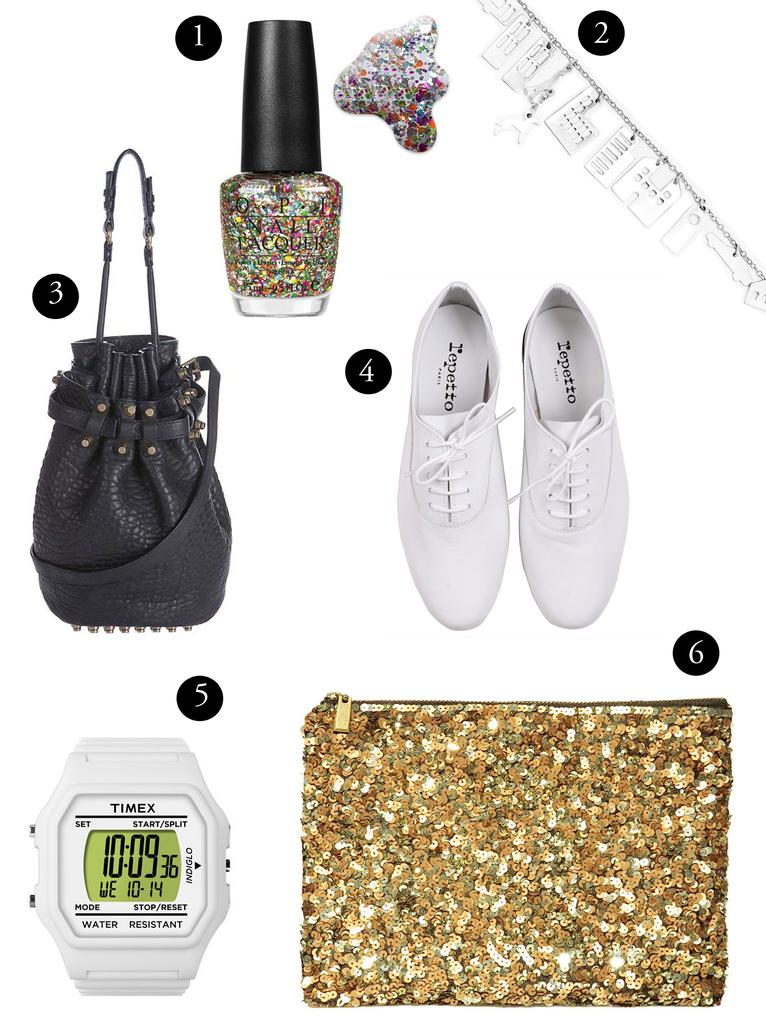<image>
Give a short and clear explanation of the subsequent image. Lots of items including a pair of Repetto shoes. 